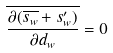<formula> <loc_0><loc_0><loc_500><loc_500>\overline { \frac { \partial ( \overline { s _ { w } } + s _ { w } ^ { \prime } ) } { \partial d _ { w } } } = 0</formula> 